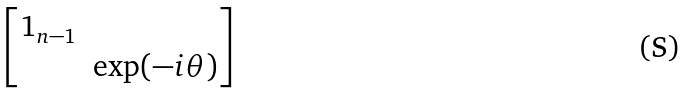Convert formula to latex. <formula><loc_0><loc_0><loc_500><loc_500>\begin{bmatrix} 1 _ { n - 1 } \\ \ & \text {exp} ( - i \theta ) \end{bmatrix}</formula> 